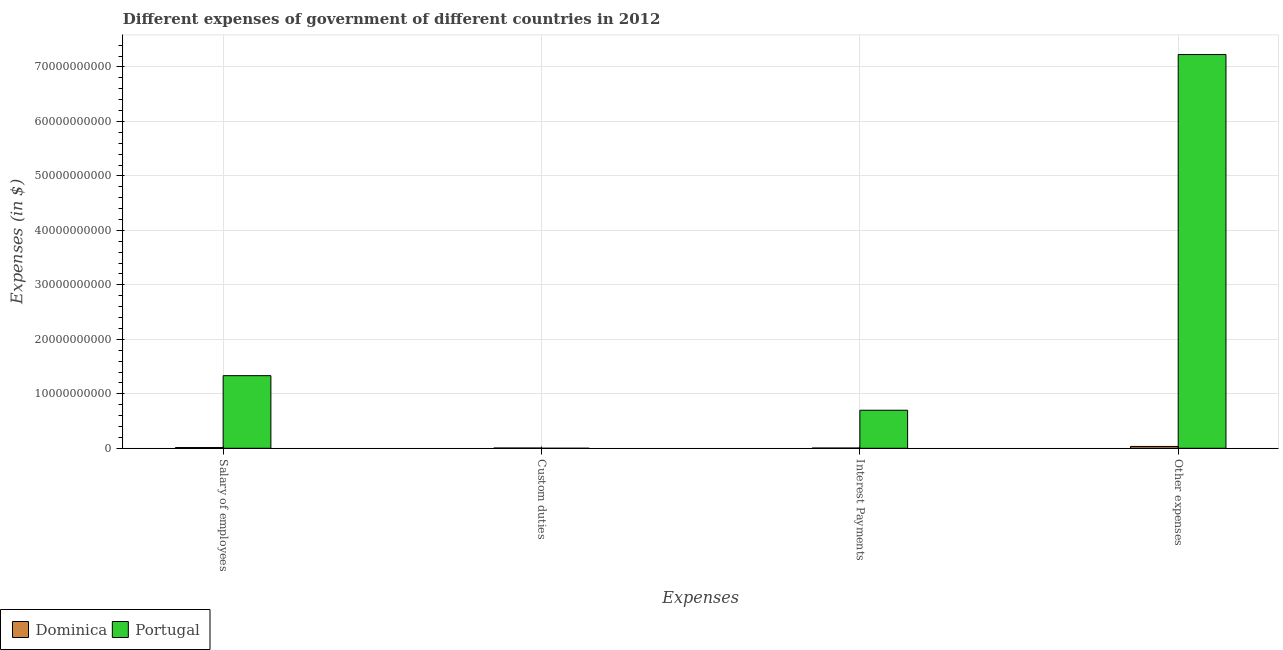How many groups of bars are there?
Ensure brevity in your answer.  4. Are the number of bars per tick equal to the number of legend labels?
Offer a terse response. Yes. Are the number of bars on each tick of the X-axis equal?
Provide a succinct answer. Yes. How many bars are there on the 2nd tick from the left?
Offer a terse response. 2. What is the label of the 4th group of bars from the left?
Offer a very short reply. Other expenses. What is the amount spent on other expenses in Portugal?
Ensure brevity in your answer.  7.23e+1. Across all countries, what is the maximum amount spent on custom duties?
Offer a terse response. 4.70e+07. Across all countries, what is the minimum amount spent on other expenses?
Ensure brevity in your answer.  3.38e+08. In which country was the amount spent on custom duties maximum?
Make the answer very short. Dominica. In which country was the amount spent on interest payments minimum?
Offer a very short reply. Dominica. What is the total amount spent on salary of employees in the graph?
Make the answer very short. 1.35e+1. What is the difference between the amount spent on interest payments in Dominica and that in Portugal?
Your answer should be compact. -6.94e+09. What is the difference between the amount spent on salary of employees in Portugal and the amount spent on custom duties in Dominica?
Your answer should be compact. 1.33e+1. What is the average amount spent on custom duties per country?
Your answer should be very brief. 2.40e+07. What is the difference between the amount spent on other expenses and amount spent on interest payments in Dominica?
Make the answer very short. 2.95e+08. In how many countries, is the amount spent on other expenses greater than 8000000000 $?
Offer a very short reply. 1. What is the ratio of the amount spent on other expenses in Dominica to that in Portugal?
Offer a terse response. 0. What is the difference between the highest and the second highest amount spent on salary of employees?
Offer a terse response. 1.32e+1. What is the difference between the highest and the lowest amount spent on salary of employees?
Provide a succinct answer. 1.32e+1. What does the 2nd bar from the left in Salary of employees represents?
Provide a succinct answer. Portugal. Are all the bars in the graph horizontal?
Offer a very short reply. No. How many countries are there in the graph?
Ensure brevity in your answer.  2. Does the graph contain grids?
Your answer should be very brief. Yes. Where does the legend appear in the graph?
Make the answer very short. Bottom left. How are the legend labels stacked?
Your answer should be very brief. Horizontal. What is the title of the graph?
Your answer should be compact. Different expenses of government of different countries in 2012. What is the label or title of the X-axis?
Your response must be concise. Expenses. What is the label or title of the Y-axis?
Your answer should be compact. Expenses (in $). What is the Expenses (in $) of Dominica in Salary of employees?
Give a very brief answer. 1.35e+08. What is the Expenses (in $) of Portugal in Salary of employees?
Offer a terse response. 1.33e+1. What is the Expenses (in $) of Dominica in Custom duties?
Offer a very short reply. 4.70e+07. What is the Expenses (in $) of Dominica in Interest Payments?
Make the answer very short. 4.33e+07. What is the Expenses (in $) of Portugal in Interest Payments?
Your answer should be compact. 6.98e+09. What is the Expenses (in $) of Dominica in Other expenses?
Keep it short and to the point. 3.38e+08. What is the Expenses (in $) of Portugal in Other expenses?
Give a very brief answer. 7.23e+1. Across all Expenses, what is the maximum Expenses (in $) in Dominica?
Your response must be concise. 3.38e+08. Across all Expenses, what is the maximum Expenses (in $) of Portugal?
Your answer should be very brief. 7.23e+1. Across all Expenses, what is the minimum Expenses (in $) of Dominica?
Provide a short and direct response. 4.33e+07. Across all Expenses, what is the minimum Expenses (in $) of Portugal?
Your response must be concise. 1.00e+06. What is the total Expenses (in $) in Dominica in the graph?
Your answer should be very brief. 5.63e+08. What is the total Expenses (in $) in Portugal in the graph?
Offer a very short reply. 9.26e+1. What is the difference between the Expenses (in $) in Dominica in Salary of employees and that in Custom duties?
Keep it short and to the point. 8.78e+07. What is the difference between the Expenses (in $) in Portugal in Salary of employees and that in Custom duties?
Your answer should be compact. 1.33e+1. What is the difference between the Expenses (in $) of Dominica in Salary of employees and that in Interest Payments?
Your answer should be compact. 9.15e+07. What is the difference between the Expenses (in $) of Portugal in Salary of employees and that in Interest Payments?
Your answer should be very brief. 6.35e+09. What is the difference between the Expenses (in $) in Dominica in Salary of employees and that in Other expenses?
Your answer should be compact. -2.03e+08. What is the difference between the Expenses (in $) in Portugal in Salary of employees and that in Other expenses?
Your answer should be compact. -5.89e+1. What is the difference between the Expenses (in $) in Dominica in Custom duties and that in Interest Payments?
Make the answer very short. 3.70e+06. What is the difference between the Expenses (in $) of Portugal in Custom duties and that in Interest Payments?
Provide a succinct answer. -6.98e+09. What is the difference between the Expenses (in $) in Dominica in Custom duties and that in Other expenses?
Provide a succinct answer. -2.91e+08. What is the difference between the Expenses (in $) of Portugal in Custom duties and that in Other expenses?
Give a very brief answer. -7.23e+1. What is the difference between the Expenses (in $) in Dominica in Interest Payments and that in Other expenses?
Provide a succinct answer. -2.95e+08. What is the difference between the Expenses (in $) of Portugal in Interest Payments and that in Other expenses?
Provide a short and direct response. -6.53e+1. What is the difference between the Expenses (in $) in Dominica in Salary of employees and the Expenses (in $) in Portugal in Custom duties?
Your answer should be very brief. 1.34e+08. What is the difference between the Expenses (in $) in Dominica in Salary of employees and the Expenses (in $) in Portugal in Interest Payments?
Ensure brevity in your answer.  -6.85e+09. What is the difference between the Expenses (in $) in Dominica in Salary of employees and the Expenses (in $) in Portugal in Other expenses?
Provide a succinct answer. -7.21e+1. What is the difference between the Expenses (in $) of Dominica in Custom duties and the Expenses (in $) of Portugal in Interest Payments?
Offer a very short reply. -6.94e+09. What is the difference between the Expenses (in $) in Dominica in Custom duties and the Expenses (in $) in Portugal in Other expenses?
Make the answer very short. -7.22e+1. What is the difference between the Expenses (in $) in Dominica in Interest Payments and the Expenses (in $) in Portugal in Other expenses?
Keep it short and to the point. -7.22e+1. What is the average Expenses (in $) of Dominica per Expenses?
Your answer should be compact. 1.41e+08. What is the average Expenses (in $) of Portugal per Expenses?
Ensure brevity in your answer.  2.31e+1. What is the difference between the Expenses (in $) of Dominica and Expenses (in $) of Portugal in Salary of employees?
Ensure brevity in your answer.  -1.32e+1. What is the difference between the Expenses (in $) in Dominica and Expenses (in $) in Portugal in Custom duties?
Offer a very short reply. 4.60e+07. What is the difference between the Expenses (in $) of Dominica and Expenses (in $) of Portugal in Interest Payments?
Keep it short and to the point. -6.94e+09. What is the difference between the Expenses (in $) of Dominica and Expenses (in $) of Portugal in Other expenses?
Offer a terse response. -7.19e+1. What is the ratio of the Expenses (in $) of Dominica in Salary of employees to that in Custom duties?
Give a very brief answer. 2.87. What is the ratio of the Expenses (in $) of Portugal in Salary of employees to that in Custom duties?
Ensure brevity in your answer.  1.33e+04. What is the ratio of the Expenses (in $) in Dominica in Salary of employees to that in Interest Payments?
Keep it short and to the point. 3.11. What is the ratio of the Expenses (in $) in Portugal in Salary of employees to that in Interest Payments?
Give a very brief answer. 1.91. What is the ratio of the Expenses (in $) in Dominica in Salary of employees to that in Other expenses?
Provide a succinct answer. 0.4. What is the ratio of the Expenses (in $) of Portugal in Salary of employees to that in Other expenses?
Offer a very short reply. 0.18. What is the ratio of the Expenses (in $) in Dominica in Custom duties to that in Interest Payments?
Offer a terse response. 1.09. What is the ratio of the Expenses (in $) in Portugal in Custom duties to that in Interest Payments?
Make the answer very short. 0. What is the ratio of the Expenses (in $) in Dominica in Custom duties to that in Other expenses?
Provide a short and direct response. 0.14. What is the ratio of the Expenses (in $) in Portugal in Custom duties to that in Other expenses?
Make the answer very short. 0. What is the ratio of the Expenses (in $) in Dominica in Interest Payments to that in Other expenses?
Offer a very short reply. 0.13. What is the ratio of the Expenses (in $) of Portugal in Interest Payments to that in Other expenses?
Your response must be concise. 0.1. What is the difference between the highest and the second highest Expenses (in $) of Dominica?
Provide a succinct answer. 2.03e+08. What is the difference between the highest and the second highest Expenses (in $) in Portugal?
Give a very brief answer. 5.89e+1. What is the difference between the highest and the lowest Expenses (in $) of Dominica?
Your answer should be compact. 2.95e+08. What is the difference between the highest and the lowest Expenses (in $) of Portugal?
Offer a terse response. 7.23e+1. 